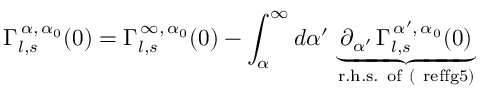Convert formula to latex. <formula><loc_0><loc_0><loc_500><loc_500>\Gamma _ { l , s } ^ { \, \alpha , \, \alpha _ { 0 } } ( 0 ) = \Gamma _ { l , s } ^ { \, \infty , \, \alpha _ { 0 } } ( 0 ) - \int _ { \alpha } ^ { \infty } d \alpha ^ { \prime } \, \underbrace { \, \partial _ { \alpha ^ { \prime } } \, \Gamma _ { l , s } ^ { \, \alpha ^ { \prime } , \, \alpha _ { 0 } } ( 0 ) \, } _ { r . h . s . o f ( \ r e f { f g 5 } ) }</formula> 